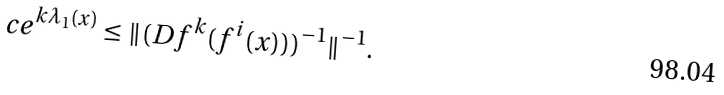Convert formula to latex. <formula><loc_0><loc_0><loc_500><loc_500>c e ^ { k \lambda _ { 1 } ( x ) } \leq \| ( D f ^ { k } ( f ^ { i } ( x ) ) ) ^ { - 1 } \| ^ { - 1 } .</formula> 